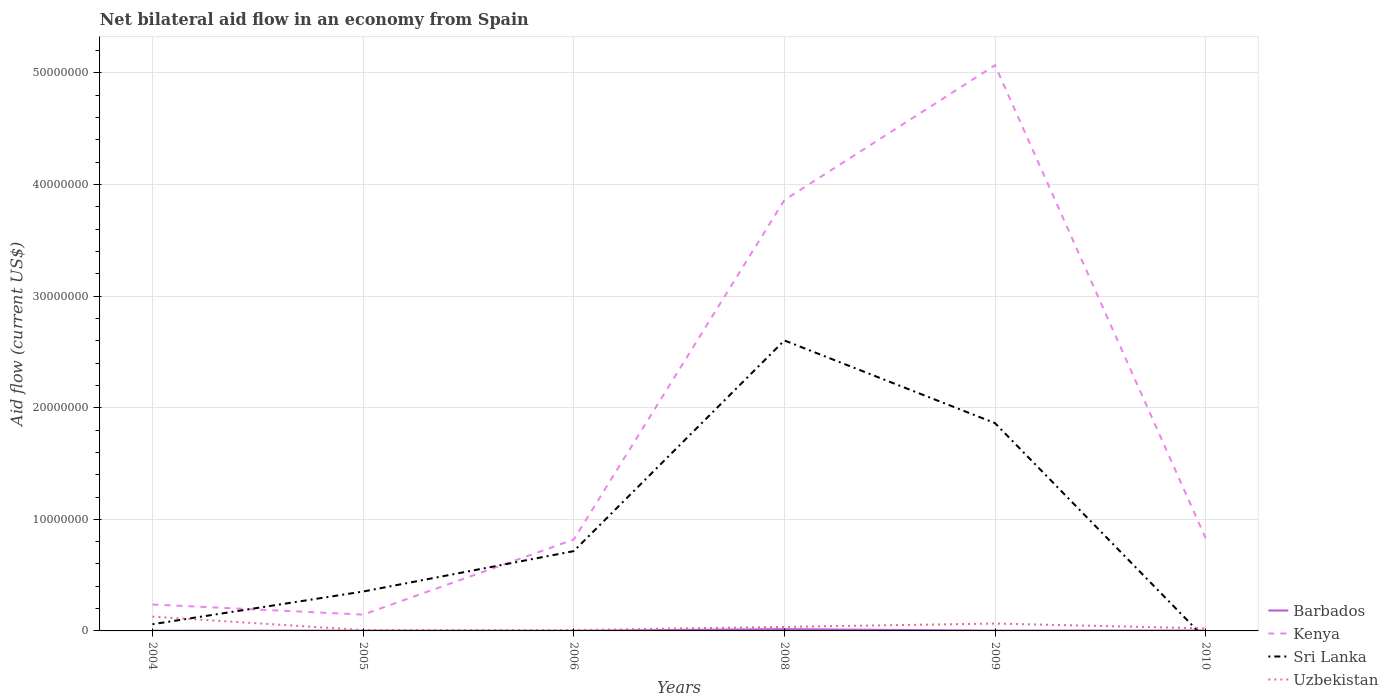How many different coloured lines are there?
Provide a succinct answer. 4. Does the line corresponding to Sri Lanka intersect with the line corresponding to Uzbekistan?
Your answer should be compact. Yes. Is the number of lines equal to the number of legend labels?
Make the answer very short. No. What is the total net bilateral aid flow in Uzbekistan in the graph?
Provide a short and direct response. 6.20e+05. What is the difference between the highest and the second highest net bilateral aid flow in Uzbekistan?
Your response must be concise. 1.20e+06. What is the difference between the highest and the lowest net bilateral aid flow in Uzbekistan?
Ensure brevity in your answer.  2. Is the net bilateral aid flow in Uzbekistan strictly greater than the net bilateral aid flow in Sri Lanka over the years?
Offer a very short reply. No. How many lines are there?
Make the answer very short. 4. What is the difference between two consecutive major ticks on the Y-axis?
Keep it short and to the point. 1.00e+07. Are the values on the major ticks of Y-axis written in scientific E-notation?
Your response must be concise. No. Does the graph contain grids?
Your response must be concise. Yes. How are the legend labels stacked?
Ensure brevity in your answer.  Vertical. What is the title of the graph?
Your response must be concise. Net bilateral aid flow in an economy from Spain. Does "China" appear as one of the legend labels in the graph?
Provide a succinct answer. No. What is the label or title of the X-axis?
Provide a short and direct response. Years. What is the Aid flow (current US$) of Barbados in 2004?
Offer a terse response. 2.00e+04. What is the Aid flow (current US$) of Kenya in 2004?
Provide a succinct answer. 2.37e+06. What is the Aid flow (current US$) of Sri Lanka in 2004?
Keep it short and to the point. 6.00e+05. What is the Aid flow (current US$) in Uzbekistan in 2004?
Make the answer very short. 1.28e+06. What is the Aid flow (current US$) of Barbados in 2005?
Your answer should be very brief. 3.00e+04. What is the Aid flow (current US$) in Kenya in 2005?
Offer a very short reply. 1.46e+06. What is the Aid flow (current US$) of Sri Lanka in 2005?
Give a very brief answer. 3.53e+06. What is the Aid flow (current US$) of Uzbekistan in 2005?
Give a very brief answer. 8.00e+04. What is the Aid flow (current US$) of Barbados in 2006?
Offer a very short reply. 2.00e+04. What is the Aid flow (current US$) of Kenya in 2006?
Make the answer very short. 8.19e+06. What is the Aid flow (current US$) of Sri Lanka in 2006?
Your answer should be very brief. 7.15e+06. What is the Aid flow (current US$) of Barbados in 2008?
Provide a short and direct response. 1.60e+05. What is the Aid flow (current US$) of Kenya in 2008?
Make the answer very short. 3.86e+07. What is the Aid flow (current US$) of Sri Lanka in 2008?
Provide a short and direct response. 2.60e+07. What is the Aid flow (current US$) in Uzbekistan in 2008?
Ensure brevity in your answer.  3.60e+05. What is the Aid flow (current US$) in Barbados in 2009?
Provide a short and direct response. 3.00e+04. What is the Aid flow (current US$) of Kenya in 2009?
Provide a succinct answer. 5.07e+07. What is the Aid flow (current US$) in Sri Lanka in 2009?
Your answer should be very brief. 1.86e+07. What is the Aid flow (current US$) of Kenya in 2010?
Offer a terse response. 8.31e+06. Across all years, what is the maximum Aid flow (current US$) in Kenya?
Provide a succinct answer. 5.07e+07. Across all years, what is the maximum Aid flow (current US$) of Sri Lanka?
Your answer should be very brief. 2.60e+07. Across all years, what is the maximum Aid flow (current US$) of Uzbekistan?
Provide a short and direct response. 1.28e+06. Across all years, what is the minimum Aid flow (current US$) in Barbados?
Your answer should be very brief. 2.00e+04. Across all years, what is the minimum Aid flow (current US$) in Kenya?
Your response must be concise. 1.46e+06. Across all years, what is the minimum Aid flow (current US$) of Uzbekistan?
Offer a very short reply. 8.00e+04. What is the total Aid flow (current US$) of Barbados in the graph?
Offer a very short reply. 3.00e+05. What is the total Aid flow (current US$) in Kenya in the graph?
Make the answer very short. 1.10e+08. What is the total Aid flow (current US$) in Sri Lanka in the graph?
Keep it short and to the point. 5.59e+07. What is the total Aid flow (current US$) of Uzbekistan in the graph?
Your response must be concise. 2.69e+06. What is the difference between the Aid flow (current US$) in Barbados in 2004 and that in 2005?
Give a very brief answer. -10000. What is the difference between the Aid flow (current US$) in Kenya in 2004 and that in 2005?
Provide a succinct answer. 9.10e+05. What is the difference between the Aid flow (current US$) of Sri Lanka in 2004 and that in 2005?
Give a very brief answer. -2.93e+06. What is the difference between the Aid flow (current US$) in Uzbekistan in 2004 and that in 2005?
Give a very brief answer. 1.20e+06. What is the difference between the Aid flow (current US$) of Barbados in 2004 and that in 2006?
Your response must be concise. 0. What is the difference between the Aid flow (current US$) of Kenya in 2004 and that in 2006?
Provide a short and direct response. -5.82e+06. What is the difference between the Aid flow (current US$) in Sri Lanka in 2004 and that in 2006?
Keep it short and to the point. -6.55e+06. What is the difference between the Aid flow (current US$) of Uzbekistan in 2004 and that in 2006?
Your answer should be compact. 1.20e+06. What is the difference between the Aid flow (current US$) in Barbados in 2004 and that in 2008?
Your answer should be compact. -1.40e+05. What is the difference between the Aid flow (current US$) in Kenya in 2004 and that in 2008?
Provide a succinct answer. -3.62e+07. What is the difference between the Aid flow (current US$) of Sri Lanka in 2004 and that in 2008?
Keep it short and to the point. -2.54e+07. What is the difference between the Aid flow (current US$) of Uzbekistan in 2004 and that in 2008?
Ensure brevity in your answer.  9.20e+05. What is the difference between the Aid flow (current US$) of Kenya in 2004 and that in 2009?
Your answer should be compact. -4.83e+07. What is the difference between the Aid flow (current US$) of Sri Lanka in 2004 and that in 2009?
Provide a short and direct response. -1.80e+07. What is the difference between the Aid flow (current US$) in Uzbekistan in 2004 and that in 2009?
Your response must be concise. 6.20e+05. What is the difference between the Aid flow (current US$) in Barbados in 2004 and that in 2010?
Provide a succinct answer. -2.00e+04. What is the difference between the Aid flow (current US$) of Kenya in 2004 and that in 2010?
Give a very brief answer. -5.94e+06. What is the difference between the Aid flow (current US$) in Uzbekistan in 2004 and that in 2010?
Provide a short and direct response. 1.05e+06. What is the difference between the Aid flow (current US$) of Kenya in 2005 and that in 2006?
Your answer should be very brief. -6.73e+06. What is the difference between the Aid flow (current US$) of Sri Lanka in 2005 and that in 2006?
Keep it short and to the point. -3.62e+06. What is the difference between the Aid flow (current US$) of Barbados in 2005 and that in 2008?
Give a very brief answer. -1.30e+05. What is the difference between the Aid flow (current US$) in Kenya in 2005 and that in 2008?
Your answer should be very brief. -3.72e+07. What is the difference between the Aid flow (current US$) of Sri Lanka in 2005 and that in 2008?
Provide a short and direct response. -2.25e+07. What is the difference between the Aid flow (current US$) of Uzbekistan in 2005 and that in 2008?
Offer a terse response. -2.80e+05. What is the difference between the Aid flow (current US$) of Barbados in 2005 and that in 2009?
Ensure brevity in your answer.  0. What is the difference between the Aid flow (current US$) in Kenya in 2005 and that in 2009?
Ensure brevity in your answer.  -4.92e+07. What is the difference between the Aid flow (current US$) of Sri Lanka in 2005 and that in 2009?
Provide a short and direct response. -1.51e+07. What is the difference between the Aid flow (current US$) of Uzbekistan in 2005 and that in 2009?
Give a very brief answer. -5.80e+05. What is the difference between the Aid flow (current US$) of Barbados in 2005 and that in 2010?
Provide a short and direct response. -10000. What is the difference between the Aid flow (current US$) in Kenya in 2005 and that in 2010?
Give a very brief answer. -6.85e+06. What is the difference between the Aid flow (current US$) of Uzbekistan in 2005 and that in 2010?
Your answer should be very brief. -1.50e+05. What is the difference between the Aid flow (current US$) of Barbados in 2006 and that in 2008?
Offer a terse response. -1.40e+05. What is the difference between the Aid flow (current US$) of Kenya in 2006 and that in 2008?
Keep it short and to the point. -3.04e+07. What is the difference between the Aid flow (current US$) in Sri Lanka in 2006 and that in 2008?
Offer a very short reply. -1.89e+07. What is the difference between the Aid flow (current US$) in Uzbekistan in 2006 and that in 2008?
Your answer should be compact. -2.80e+05. What is the difference between the Aid flow (current US$) of Barbados in 2006 and that in 2009?
Provide a short and direct response. -10000. What is the difference between the Aid flow (current US$) of Kenya in 2006 and that in 2009?
Offer a terse response. -4.25e+07. What is the difference between the Aid flow (current US$) of Sri Lanka in 2006 and that in 2009?
Make the answer very short. -1.15e+07. What is the difference between the Aid flow (current US$) in Uzbekistan in 2006 and that in 2009?
Your answer should be very brief. -5.80e+05. What is the difference between the Aid flow (current US$) in Barbados in 2006 and that in 2010?
Your response must be concise. -2.00e+04. What is the difference between the Aid flow (current US$) in Kenya in 2006 and that in 2010?
Provide a succinct answer. -1.20e+05. What is the difference between the Aid flow (current US$) in Uzbekistan in 2006 and that in 2010?
Your answer should be compact. -1.50e+05. What is the difference between the Aid flow (current US$) in Kenya in 2008 and that in 2009?
Give a very brief answer. -1.21e+07. What is the difference between the Aid flow (current US$) of Sri Lanka in 2008 and that in 2009?
Provide a succinct answer. 7.41e+06. What is the difference between the Aid flow (current US$) of Kenya in 2008 and that in 2010?
Your response must be concise. 3.03e+07. What is the difference between the Aid flow (current US$) in Barbados in 2009 and that in 2010?
Provide a short and direct response. -10000. What is the difference between the Aid flow (current US$) in Kenya in 2009 and that in 2010?
Your answer should be very brief. 4.24e+07. What is the difference between the Aid flow (current US$) in Uzbekistan in 2009 and that in 2010?
Provide a succinct answer. 4.30e+05. What is the difference between the Aid flow (current US$) of Barbados in 2004 and the Aid flow (current US$) of Kenya in 2005?
Your answer should be very brief. -1.44e+06. What is the difference between the Aid flow (current US$) of Barbados in 2004 and the Aid flow (current US$) of Sri Lanka in 2005?
Offer a very short reply. -3.51e+06. What is the difference between the Aid flow (current US$) of Barbados in 2004 and the Aid flow (current US$) of Uzbekistan in 2005?
Your answer should be very brief. -6.00e+04. What is the difference between the Aid flow (current US$) in Kenya in 2004 and the Aid flow (current US$) in Sri Lanka in 2005?
Your answer should be compact. -1.16e+06. What is the difference between the Aid flow (current US$) of Kenya in 2004 and the Aid flow (current US$) of Uzbekistan in 2005?
Offer a terse response. 2.29e+06. What is the difference between the Aid flow (current US$) in Sri Lanka in 2004 and the Aid flow (current US$) in Uzbekistan in 2005?
Your response must be concise. 5.20e+05. What is the difference between the Aid flow (current US$) of Barbados in 2004 and the Aid flow (current US$) of Kenya in 2006?
Provide a succinct answer. -8.17e+06. What is the difference between the Aid flow (current US$) in Barbados in 2004 and the Aid flow (current US$) in Sri Lanka in 2006?
Provide a succinct answer. -7.13e+06. What is the difference between the Aid flow (current US$) of Kenya in 2004 and the Aid flow (current US$) of Sri Lanka in 2006?
Your answer should be compact. -4.78e+06. What is the difference between the Aid flow (current US$) in Kenya in 2004 and the Aid flow (current US$) in Uzbekistan in 2006?
Provide a succinct answer. 2.29e+06. What is the difference between the Aid flow (current US$) of Sri Lanka in 2004 and the Aid flow (current US$) of Uzbekistan in 2006?
Provide a short and direct response. 5.20e+05. What is the difference between the Aid flow (current US$) in Barbados in 2004 and the Aid flow (current US$) in Kenya in 2008?
Ensure brevity in your answer.  -3.86e+07. What is the difference between the Aid flow (current US$) in Barbados in 2004 and the Aid flow (current US$) in Sri Lanka in 2008?
Give a very brief answer. -2.60e+07. What is the difference between the Aid flow (current US$) in Kenya in 2004 and the Aid flow (current US$) in Sri Lanka in 2008?
Ensure brevity in your answer.  -2.37e+07. What is the difference between the Aid flow (current US$) of Kenya in 2004 and the Aid flow (current US$) of Uzbekistan in 2008?
Ensure brevity in your answer.  2.01e+06. What is the difference between the Aid flow (current US$) of Barbados in 2004 and the Aid flow (current US$) of Kenya in 2009?
Provide a short and direct response. -5.07e+07. What is the difference between the Aid flow (current US$) of Barbados in 2004 and the Aid flow (current US$) of Sri Lanka in 2009?
Your response must be concise. -1.86e+07. What is the difference between the Aid flow (current US$) in Barbados in 2004 and the Aid flow (current US$) in Uzbekistan in 2009?
Keep it short and to the point. -6.40e+05. What is the difference between the Aid flow (current US$) in Kenya in 2004 and the Aid flow (current US$) in Sri Lanka in 2009?
Your answer should be compact. -1.62e+07. What is the difference between the Aid flow (current US$) in Kenya in 2004 and the Aid flow (current US$) in Uzbekistan in 2009?
Keep it short and to the point. 1.71e+06. What is the difference between the Aid flow (current US$) of Sri Lanka in 2004 and the Aid flow (current US$) of Uzbekistan in 2009?
Provide a short and direct response. -6.00e+04. What is the difference between the Aid flow (current US$) of Barbados in 2004 and the Aid flow (current US$) of Kenya in 2010?
Offer a terse response. -8.29e+06. What is the difference between the Aid flow (current US$) in Kenya in 2004 and the Aid flow (current US$) in Uzbekistan in 2010?
Your answer should be compact. 2.14e+06. What is the difference between the Aid flow (current US$) of Barbados in 2005 and the Aid flow (current US$) of Kenya in 2006?
Provide a short and direct response. -8.16e+06. What is the difference between the Aid flow (current US$) of Barbados in 2005 and the Aid flow (current US$) of Sri Lanka in 2006?
Your response must be concise. -7.12e+06. What is the difference between the Aid flow (current US$) of Barbados in 2005 and the Aid flow (current US$) of Uzbekistan in 2006?
Offer a terse response. -5.00e+04. What is the difference between the Aid flow (current US$) of Kenya in 2005 and the Aid flow (current US$) of Sri Lanka in 2006?
Offer a very short reply. -5.69e+06. What is the difference between the Aid flow (current US$) in Kenya in 2005 and the Aid flow (current US$) in Uzbekistan in 2006?
Make the answer very short. 1.38e+06. What is the difference between the Aid flow (current US$) of Sri Lanka in 2005 and the Aid flow (current US$) of Uzbekistan in 2006?
Keep it short and to the point. 3.45e+06. What is the difference between the Aid flow (current US$) of Barbados in 2005 and the Aid flow (current US$) of Kenya in 2008?
Provide a succinct answer. -3.86e+07. What is the difference between the Aid flow (current US$) in Barbados in 2005 and the Aid flow (current US$) in Sri Lanka in 2008?
Provide a short and direct response. -2.60e+07. What is the difference between the Aid flow (current US$) of Barbados in 2005 and the Aid flow (current US$) of Uzbekistan in 2008?
Your response must be concise. -3.30e+05. What is the difference between the Aid flow (current US$) of Kenya in 2005 and the Aid flow (current US$) of Sri Lanka in 2008?
Offer a very short reply. -2.46e+07. What is the difference between the Aid flow (current US$) of Kenya in 2005 and the Aid flow (current US$) of Uzbekistan in 2008?
Provide a short and direct response. 1.10e+06. What is the difference between the Aid flow (current US$) of Sri Lanka in 2005 and the Aid flow (current US$) of Uzbekistan in 2008?
Make the answer very short. 3.17e+06. What is the difference between the Aid flow (current US$) in Barbados in 2005 and the Aid flow (current US$) in Kenya in 2009?
Make the answer very short. -5.07e+07. What is the difference between the Aid flow (current US$) of Barbados in 2005 and the Aid flow (current US$) of Sri Lanka in 2009?
Ensure brevity in your answer.  -1.86e+07. What is the difference between the Aid flow (current US$) in Barbados in 2005 and the Aid flow (current US$) in Uzbekistan in 2009?
Make the answer very short. -6.30e+05. What is the difference between the Aid flow (current US$) of Kenya in 2005 and the Aid flow (current US$) of Sri Lanka in 2009?
Provide a succinct answer. -1.72e+07. What is the difference between the Aid flow (current US$) of Kenya in 2005 and the Aid flow (current US$) of Uzbekistan in 2009?
Make the answer very short. 8.00e+05. What is the difference between the Aid flow (current US$) of Sri Lanka in 2005 and the Aid flow (current US$) of Uzbekistan in 2009?
Keep it short and to the point. 2.87e+06. What is the difference between the Aid flow (current US$) in Barbados in 2005 and the Aid flow (current US$) in Kenya in 2010?
Your response must be concise. -8.28e+06. What is the difference between the Aid flow (current US$) in Kenya in 2005 and the Aid flow (current US$) in Uzbekistan in 2010?
Make the answer very short. 1.23e+06. What is the difference between the Aid flow (current US$) in Sri Lanka in 2005 and the Aid flow (current US$) in Uzbekistan in 2010?
Ensure brevity in your answer.  3.30e+06. What is the difference between the Aid flow (current US$) in Barbados in 2006 and the Aid flow (current US$) in Kenya in 2008?
Keep it short and to the point. -3.86e+07. What is the difference between the Aid flow (current US$) in Barbados in 2006 and the Aid flow (current US$) in Sri Lanka in 2008?
Your answer should be compact. -2.60e+07. What is the difference between the Aid flow (current US$) of Kenya in 2006 and the Aid flow (current US$) of Sri Lanka in 2008?
Keep it short and to the point. -1.78e+07. What is the difference between the Aid flow (current US$) in Kenya in 2006 and the Aid flow (current US$) in Uzbekistan in 2008?
Keep it short and to the point. 7.83e+06. What is the difference between the Aid flow (current US$) in Sri Lanka in 2006 and the Aid flow (current US$) in Uzbekistan in 2008?
Your answer should be very brief. 6.79e+06. What is the difference between the Aid flow (current US$) of Barbados in 2006 and the Aid flow (current US$) of Kenya in 2009?
Your answer should be very brief. -5.07e+07. What is the difference between the Aid flow (current US$) of Barbados in 2006 and the Aid flow (current US$) of Sri Lanka in 2009?
Give a very brief answer. -1.86e+07. What is the difference between the Aid flow (current US$) of Barbados in 2006 and the Aid flow (current US$) of Uzbekistan in 2009?
Your answer should be compact. -6.40e+05. What is the difference between the Aid flow (current US$) in Kenya in 2006 and the Aid flow (current US$) in Sri Lanka in 2009?
Offer a very short reply. -1.04e+07. What is the difference between the Aid flow (current US$) in Kenya in 2006 and the Aid flow (current US$) in Uzbekistan in 2009?
Give a very brief answer. 7.53e+06. What is the difference between the Aid flow (current US$) of Sri Lanka in 2006 and the Aid flow (current US$) of Uzbekistan in 2009?
Offer a very short reply. 6.49e+06. What is the difference between the Aid flow (current US$) in Barbados in 2006 and the Aid flow (current US$) in Kenya in 2010?
Provide a succinct answer. -8.29e+06. What is the difference between the Aid flow (current US$) of Kenya in 2006 and the Aid flow (current US$) of Uzbekistan in 2010?
Offer a very short reply. 7.96e+06. What is the difference between the Aid flow (current US$) of Sri Lanka in 2006 and the Aid flow (current US$) of Uzbekistan in 2010?
Make the answer very short. 6.92e+06. What is the difference between the Aid flow (current US$) of Barbados in 2008 and the Aid flow (current US$) of Kenya in 2009?
Make the answer very short. -5.05e+07. What is the difference between the Aid flow (current US$) of Barbados in 2008 and the Aid flow (current US$) of Sri Lanka in 2009?
Offer a terse response. -1.85e+07. What is the difference between the Aid flow (current US$) in Barbados in 2008 and the Aid flow (current US$) in Uzbekistan in 2009?
Your answer should be very brief. -5.00e+05. What is the difference between the Aid flow (current US$) of Kenya in 2008 and the Aid flow (current US$) of Sri Lanka in 2009?
Give a very brief answer. 2.00e+07. What is the difference between the Aid flow (current US$) in Kenya in 2008 and the Aid flow (current US$) in Uzbekistan in 2009?
Keep it short and to the point. 3.80e+07. What is the difference between the Aid flow (current US$) in Sri Lanka in 2008 and the Aid flow (current US$) in Uzbekistan in 2009?
Offer a terse response. 2.54e+07. What is the difference between the Aid flow (current US$) of Barbados in 2008 and the Aid flow (current US$) of Kenya in 2010?
Make the answer very short. -8.15e+06. What is the difference between the Aid flow (current US$) of Kenya in 2008 and the Aid flow (current US$) of Uzbekistan in 2010?
Your answer should be very brief. 3.84e+07. What is the difference between the Aid flow (current US$) of Sri Lanka in 2008 and the Aid flow (current US$) of Uzbekistan in 2010?
Provide a short and direct response. 2.58e+07. What is the difference between the Aid flow (current US$) of Barbados in 2009 and the Aid flow (current US$) of Kenya in 2010?
Offer a terse response. -8.28e+06. What is the difference between the Aid flow (current US$) in Barbados in 2009 and the Aid flow (current US$) in Uzbekistan in 2010?
Your response must be concise. -2.00e+05. What is the difference between the Aid flow (current US$) in Kenya in 2009 and the Aid flow (current US$) in Uzbekistan in 2010?
Provide a succinct answer. 5.05e+07. What is the difference between the Aid flow (current US$) of Sri Lanka in 2009 and the Aid flow (current US$) of Uzbekistan in 2010?
Your answer should be compact. 1.84e+07. What is the average Aid flow (current US$) in Kenya per year?
Give a very brief answer. 1.83e+07. What is the average Aid flow (current US$) in Sri Lanka per year?
Your answer should be compact. 9.32e+06. What is the average Aid flow (current US$) in Uzbekistan per year?
Make the answer very short. 4.48e+05. In the year 2004, what is the difference between the Aid flow (current US$) of Barbados and Aid flow (current US$) of Kenya?
Give a very brief answer. -2.35e+06. In the year 2004, what is the difference between the Aid flow (current US$) in Barbados and Aid flow (current US$) in Sri Lanka?
Provide a short and direct response. -5.80e+05. In the year 2004, what is the difference between the Aid flow (current US$) of Barbados and Aid flow (current US$) of Uzbekistan?
Give a very brief answer. -1.26e+06. In the year 2004, what is the difference between the Aid flow (current US$) of Kenya and Aid flow (current US$) of Sri Lanka?
Make the answer very short. 1.77e+06. In the year 2004, what is the difference between the Aid flow (current US$) of Kenya and Aid flow (current US$) of Uzbekistan?
Offer a terse response. 1.09e+06. In the year 2004, what is the difference between the Aid flow (current US$) in Sri Lanka and Aid flow (current US$) in Uzbekistan?
Offer a terse response. -6.80e+05. In the year 2005, what is the difference between the Aid flow (current US$) of Barbados and Aid flow (current US$) of Kenya?
Make the answer very short. -1.43e+06. In the year 2005, what is the difference between the Aid flow (current US$) of Barbados and Aid flow (current US$) of Sri Lanka?
Offer a very short reply. -3.50e+06. In the year 2005, what is the difference between the Aid flow (current US$) of Barbados and Aid flow (current US$) of Uzbekistan?
Make the answer very short. -5.00e+04. In the year 2005, what is the difference between the Aid flow (current US$) of Kenya and Aid flow (current US$) of Sri Lanka?
Your response must be concise. -2.07e+06. In the year 2005, what is the difference between the Aid flow (current US$) of Kenya and Aid flow (current US$) of Uzbekistan?
Ensure brevity in your answer.  1.38e+06. In the year 2005, what is the difference between the Aid flow (current US$) of Sri Lanka and Aid flow (current US$) of Uzbekistan?
Your response must be concise. 3.45e+06. In the year 2006, what is the difference between the Aid flow (current US$) in Barbados and Aid flow (current US$) in Kenya?
Keep it short and to the point. -8.17e+06. In the year 2006, what is the difference between the Aid flow (current US$) in Barbados and Aid flow (current US$) in Sri Lanka?
Ensure brevity in your answer.  -7.13e+06. In the year 2006, what is the difference between the Aid flow (current US$) of Barbados and Aid flow (current US$) of Uzbekistan?
Your response must be concise. -6.00e+04. In the year 2006, what is the difference between the Aid flow (current US$) in Kenya and Aid flow (current US$) in Sri Lanka?
Keep it short and to the point. 1.04e+06. In the year 2006, what is the difference between the Aid flow (current US$) of Kenya and Aid flow (current US$) of Uzbekistan?
Your answer should be compact. 8.11e+06. In the year 2006, what is the difference between the Aid flow (current US$) in Sri Lanka and Aid flow (current US$) in Uzbekistan?
Provide a succinct answer. 7.07e+06. In the year 2008, what is the difference between the Aid flow (current US$) in Barbados and Aid flow (current US$) in Kenya?
Your answer should be compact. -3.84e+07. In the year 2008, what is the difference between the Aid flow (current US$) of Barbados and Aid flow (current US$) of Sri Lanka?
Provide a succinct answer. -2.59e+07. In the year 2008, what is the difference between the Aid flow (current US$) in Kenya and Aid flow (current US$) in Sri Lanka?
Your response must be concise. 1.26e+07. In the year 2008, what is the difference between the Aid flow (current US$) of Kenya and Aid flow (current US$) of Uzbekistan?
Provide a succinct answer. 3.82e+07. In the year 2008, what is the difference between the Aid flow (current US$) of Sri Lanka and Aid flow (current US$) of Uzbekistan?
Provide a succinct answer. 2.57e+07. In the year 2009, what is the difference between the Aid flow (current US$) in Barbados and Aid flow (current US$) in Kenya?
Provide a short and direct response. -5.07e+07. In the year 2009, what is the difference between the Aid flow (current US$) of Barbados and Aid flow (current US$) of Sri Lanka?
Ensure brevity in your answer.  -1.86e+07. In the year 2009, what is the difference between the Aid flow (current US$) of Barbados and Aid flow (current US$) of Uzbekistan?
Keep it short and to the point. -6.30e+05. In the year 2009, what is the difference between the Aid flow (current US$) in Kenya and Aid flow (current US$) in Sri Lanka?
Give a very brief answer. 3.21e+07. In the year 2009, what is the difference between the Aid flow (current US$) of Kenya and Aid flow (current US$) of Uzbekistan?
Your answer should be compact. 5.00e+07. In the year 2009, what is the difference between the Aid flow (current US$) of Sri Lanka and Aid flow (current US$) of Uzbekistan?
Your answer should be compact. 1.80e+07. In the year 2010, what is the difference between the Aid flow (current US$) in Barbados and Aid flow (current US$) in Kenya?
Provide a succinct answer. -8.27e+06. In the year 2010, what is the difference between the Aid flow (current US$) of Barbados and Aid flow (current US$) of Uzbekistan?
Offer a very short reply. -1.90e+05. In the year 2010, what is the difference between the Aid flow (current US$) of Kenya and Aid flow (current US$) of Uzbekistan?
Your answer should be compact. 8.08e+06. What is the ratio of the Aid flow (current US$) of Kenya in 2004 to that in 2005?
Your answer should be compact. 1.62. What is the ratio of the Aid flow (current US$) of Sri Lanka in 2004 to that in 2005?
Ensure brevity in your answer.  0.17. What is the ratio of the Aid flow (current US$) of Uzbekistan in 2004 to that in 2005?
Provide a short and direct response. 16. What is the ratio of the Aid flow (current US$) in Barbados in 2004 to that in 2006?
Ensure brevity in your answer.  1. What is the ratio of the Aid flow (current US$) in Kenya in 2004 to that in 2006?
Give a very brief answer. 0.29. What is the ratio of the Aid flow (current US$) in Sri Lanka in 2004 to that in 2006?
Provide a succinct answer. 0.08. What is the ratio of the Aid flow (current US$) of Uzbekistan in 2004 to that in 2006?
Your response must be concise. 16. What is the ratio of the Aid flow (current US$) of Barbados in 2004 to that in 2008?
Make the answer very short. 0.12. What is the ratio of the Aid flow (current US$) in Kenya in 2004 to that in 2008?
Provide a succinct answer. 0.06. What is the ratio of the Aid flow (current US$) of Sri Lanka in 2004 to that in 2008?
Offer a very short reply. 0.02. What is the ratio of the Aid flow (current US$) of Uzbekistan in 2004 to that in 2008?
Keep it short and to the point. 3.56. What is the ratio of the Aid flow (current US$) of Barbados in 2004 to that in 2009?
Ensure brevity in your answer.  0.67. What is the ratio of the Aid flow (current US$) in Kenya in 2004 to that in 2009?
Offer a terse response. 0.05. What is the ratio of the Aid flow (current US$) of Sri Lanka in 2004 to that in 2009?
Provide a succinct answer. 0.03. What is the ratio of the Aid flow (current US$) of Uzbekistan in 2004 to that in 2009?
Your answer should be very brief. 1.94. What is the ratio of the Aid flow (current US$) of Barbados in 2004 to that in 2010?
Make the answer very short. 0.5. What is the ratio of the Aid flow (current US$) in Kenya in 2004 to that in 2010?
Provide a short and direct response. 0.29. What is the ratio of the Aid flow (current US$) of Uzbekistan in 2004 to that in 2010?
Your response must be concise. 5.57. What is the ratio of the Aid flow (current US$) of Barbados in 2005 to that in 2006?
Provide a short and direct response. 1.5. What is the ratio of the Aid flow (current US$) of Kenya in 2005 to that in 2006?
Your response must be concise. 0.18. What is the ratio of the Aid flow (current US$) in Sri Lanka in 2005 to that in 2006?
Give a very brief answer. 0.49. What is the ratio of the Aid flow (current US$) in Barbados in 2005 to that in 2008?
Keep it short and to the point. 0.19. What is the ratio of the Aid flow (current US$) of Kenya in 2005 to that in 2008?
Give a very brief answer. 0.04. What is the ratio of the Aid flow (current US$) in Sri Lanka in 2005 to that in 2008?
Ensure brevity in your answer.  0.14. What is the ratio of the Aid flow (current US$) of Uzbekistan in 2005 to that in 2008?
Your answer should be compact. 0.22. What is the ratio of the Aid flow (current US$) of Kenya in 2005 to that in 2009?
Give a very brief answer. 0.03. What is the ratio of the Aid flow (current US$) of Sri Lanka in 2005 to that in 2009?
Ensure brevity in your answer.  0.19. What is the ratio of the Aid flow (current US$) of Uzbekistan in 2005 to that in 2009?
Offer a terse response. 0.12. What is the ratio of the Aid flow (current US$) of Kenya in 2005 to that in 2010?
Offer a terse response. 0.18. What is the ratio of the Aid flow (current US$) of Uzbekistan in 2005 to that in 2010?
Your response must be concise. 0.35. What is the ratio of the Aid flow (current US$) of Barbados in 2006 to that in 2008?
Offer a very short reply. 0.12. What is the ratio of the Aid flow (current US$) of Kenya in 2006 to that in 2008?
Provide a succinct answer. 0.21. What is the ratio of the Aid flow (current US$) of Sri Lanka in 2006 to that in 2008?
Offer a very short reply. 0.27. What is the ratio of the Aid flow (current US$) in Uzbekistan in 2006 to that in 2008?
Your answer should be very brief. 0.22. What is the ratio of the Aid flow (current US$) of Barbados in 2006 to that in 2009?
Give a very brief answer. 0.67. What is the ratio of the Aid flow (current US$) of Kenya in 2006 to that in 2009?
Keep it short and to the point. 0.16. What is the ratio of the Aid flow (current US$) in Sri Lanka in 2006 to that in 2009?
Your response must be concise. 0.38. What is the ratio of the Aid flow (current US$) in Uzbekistan in 2006 to that in 2009?
Make the answer very short. 0.12. What is the ratio of the Aid flow (current US$) in Kenya in 2006 to that in 2010?
Provide a succinct answer. 0.99. What is the ratio of the Aid flow (current US$) of Uzbekistan in 2006 to that in 2010?
Keep it short and to the point. 0.35. What is the ratio of the Aid flow (current US$) in Barbados in 2008 to that in 2009?
Your answer should be compact. 5.33. What is the ratio of the Aid flow (current US$) in Kenya in 2008 to that in 2009?
Offer a very short reply. 0.76. What is the ratio of the Aid flow (current US$) in Sri Lanka in 2008 to that in 2009?
Ensure brevity in your answer.  1.4. What is the ratio of the Aid flow (current US$) of Uzbekistan in 2008 to that in 2009?
Ensure brevity in your answer.  0.55. What is the ratio of the Aid flow (current US$) of Kenya in 2008 to that in 2010?
Ensure brevity in your answer.  4.65. What is the ratio of the Aid flow (current US$) of Uzbekistan in 2008 to that in 2010?
Make the answer very short. 1.57. What is the ratio of the Aid flow (current US$) of Barbados in 2009 to that in 2010?
Your response must be concise. 0.75. What is the ratio of the Aid flow (current US$) of Kenya in 2009 to that in 2010?
Your answer should be very brief. 6.1. What is the ratio of the Aid flow (current US$) of Uzbekistan in 2009 to that in 2010?
Your answer should be very brief. 2.87. What is the difference between the highest and the second highest Aid flow (current US$) of Kenya?
Ensure brevity in your answer.  1.21e+07. What is the difference between the highest and the second highest Aid flow (current US$) in Sri Lanka?
Offer a very short reply. 7.41e+06. What is the difference between the highest and the second highest Aid flow (current US$) of Uzbekistan?
Offer a very short reply. 6.20e+05. What is the difference between the highest and the lowest Aid flow (current US$) in Barbados?
Your response must be concise. 1.40e+05. What is the difference between the highest and the lowest Aid flow (current US$) in Kenya?
Your response must be concise. 4.92e+07. What is the difference between the highest and the lowest Aid flow (current US$) in Sri Lanka?
Make the answer very short. 2.60e+07. What is the difference between the highest and the lowest Aid flow (current US$) of Uzbekistan?
Your answer should be very brief. 1.20e+06. 